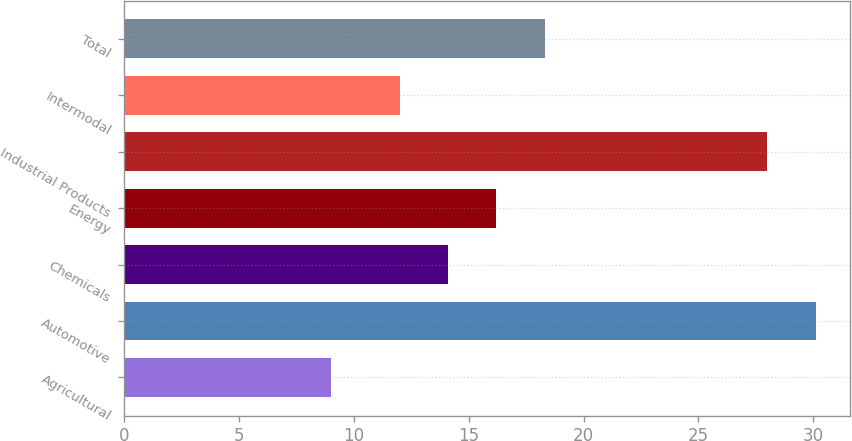Convert chart to OTSL. <chart><loc_0><loc_0><loc_500><loc_500><bar_chart><fcel>Agricultural<fcel>Automotive<fcel>Chemicals<fcel>Energy<fcel>Industrial Products<fcel>Intermodal<fcel>Total<nl><fcel>9<fcel>30.1<fcel>14.1<fcel>16.2<fcel>28<fcel>12<fcel>18.3<nl></chart> 